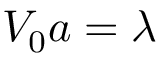<formula> <loc_0><loc_0><loc_500><loc_500>V _ { 0 } a = \lambda</formula> 